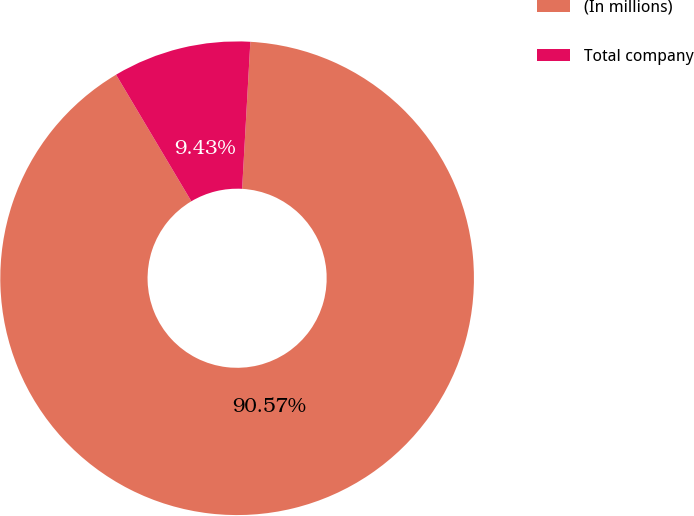Convert chart to OTSL. <chart><loc_0><loc_0><loc_500><loc_500><pie_chart><fcel>(In millions)<fcel>Total company<nl><fcel>90.57%<fcel>9.43%<nl></chart> 